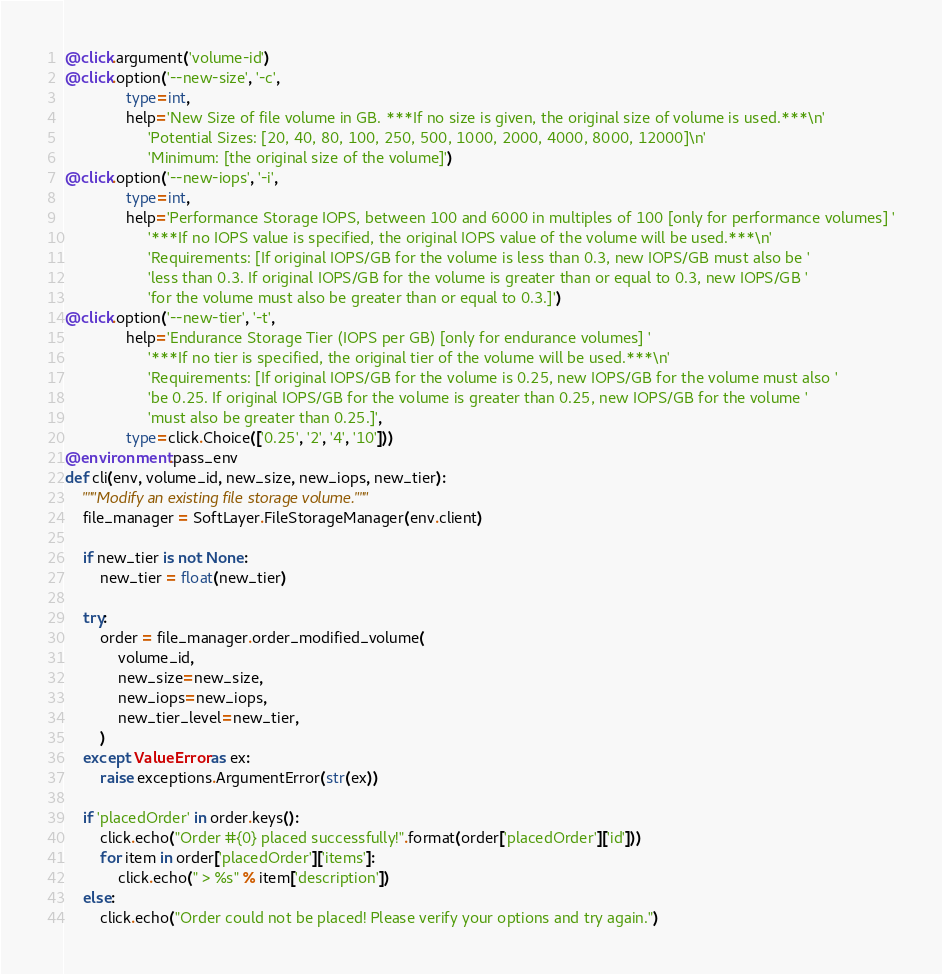<code> <loc_0><loc_0><loc_500><loc_500><_Python_>@click.argument('volume-id')
@click.option('--new-size', '-c',
              type=int,
              help='New Size of file volume in GB. ***If no size is given, the original size of volume is used.***\n'
                   'Potential Sizes: [20, 40, 80, 100, 250, 500, 1000, 2000, 4000, 8000, 12000]\n'
                   'Minimum: [the original size of the volume]')
@click.option('--new-iops', '-i',
              type=int,
              help='Performance Storage IOPS, between 100 and 6000 in multiples of 100 [only for performance volumes] '
                   '***If no IOPS value is specified, the original IOPS value of the volume will be used.***\n'
                   'Requirements: [If original IOPS/GB for the volume is less than 0.3, new IOPS/GB must also be '
                   'less than 0.3. If original IOPS/GB for the volume is greater than or equal to 0.3, new IOPS/GB '
                   'for the volume must also be greater than or equal to 0.3.]')
@click.option('--new-tier', '-t',
              help='Endurance Storage Tier (IOPS per GB) [only for endurance volumes] '
                   '***If no tier is specified, the original tier of the volume will be used.***\n'
                   'Requirements: [If original IOPS/GB for the volume is 0.25, new IOPS/GB for the volume must also '
                   'be 0.25. If original IOPS/GB for the volume is greater than 0.25, new IOPS/GB for the volume '
                   'must also be greater than 0.25.]',
              type=click.Choice(['0.25', '2', '4', '10']))
@environment.pass_env
def cli(env, volume_id, new_size, new_iops, new_tier):
    """Modify an existing file storage volume."""
    file_manager = SoftLayer.FileStorageManager(env.client)

    if new_tier is not None:
        new_tier = float(new_tier)

    try:
        order = file_manager.order_modified_volume(
            volume_id,
            new_size=new_size,
            new_iops=new_iops,
            new_tier_level=new_tier,
        )
    except ValueError as ex:
        raise exceptions.ArgumentError(str(ex))

    if 'placedOrder' in order.keys():
        click.echo("Order #{0} placed successfully!".format(order['placedOrder']['id']))
        for item in order['placedOrder']['items']:
            click.echo(" > %s" % item['description'])
    else:
        click.echo("Order could not be placed! Please verify your options and try again.")
</code> 